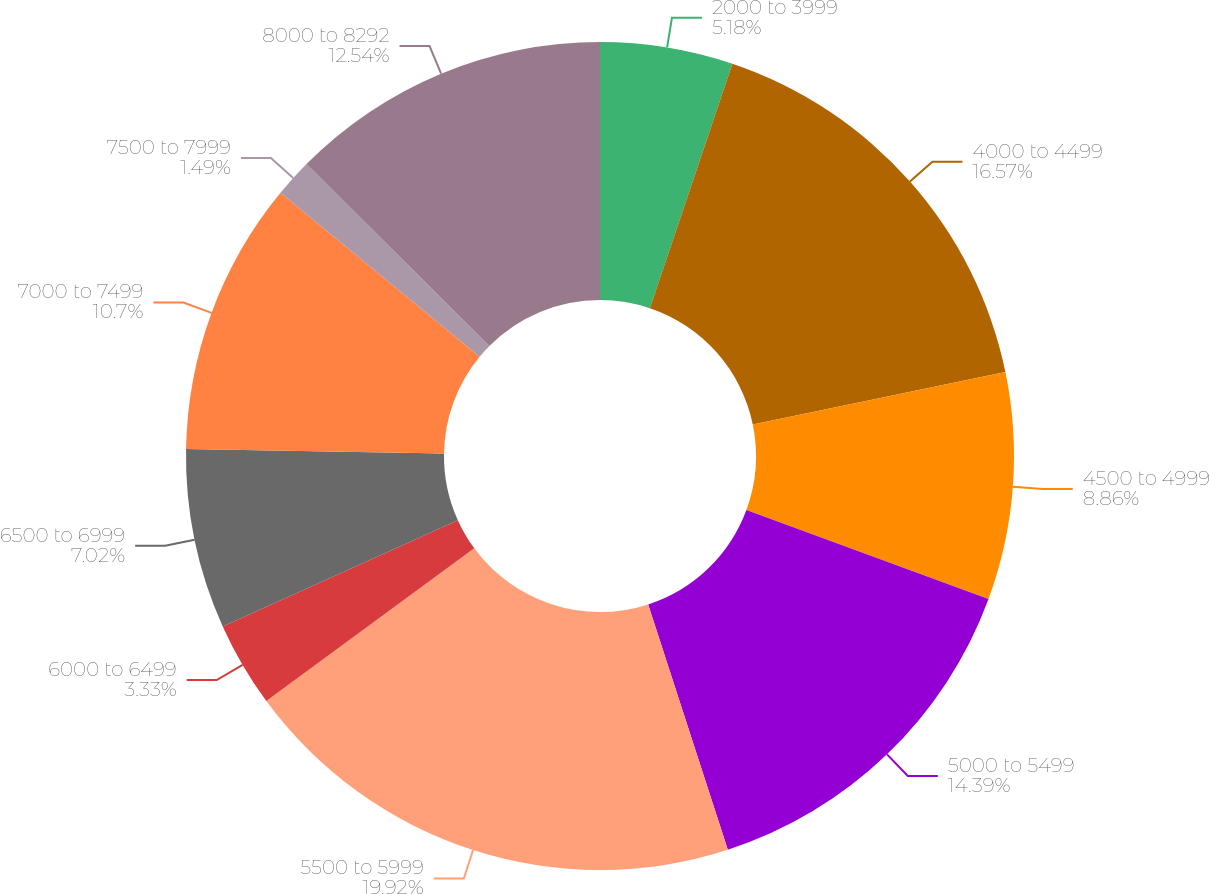Convert chart. <chart><loc_0><loc_0><loc_500><loc_500><pie_chart><fcel>2000 to 3999<fcel>4000 to 4499<fcel>4500 to 4999<fcel>5000 to 5499<fcel>5500 to 5999<fcel>6000 to 6499<fcel>6500 to 6999<fcel>7000 to 7499<fcel>7500 to 7999<fcel>8000 to 8292<nl><fcel>5.18%<fcel>16.57%<fcel>8.86%<fcel>14.39%<fcel>19.91%<fcel>3.33%<fcel>7.02%<fcel>10.7%<fcel>1.49%<fcel>12.54%<nl></chart> 